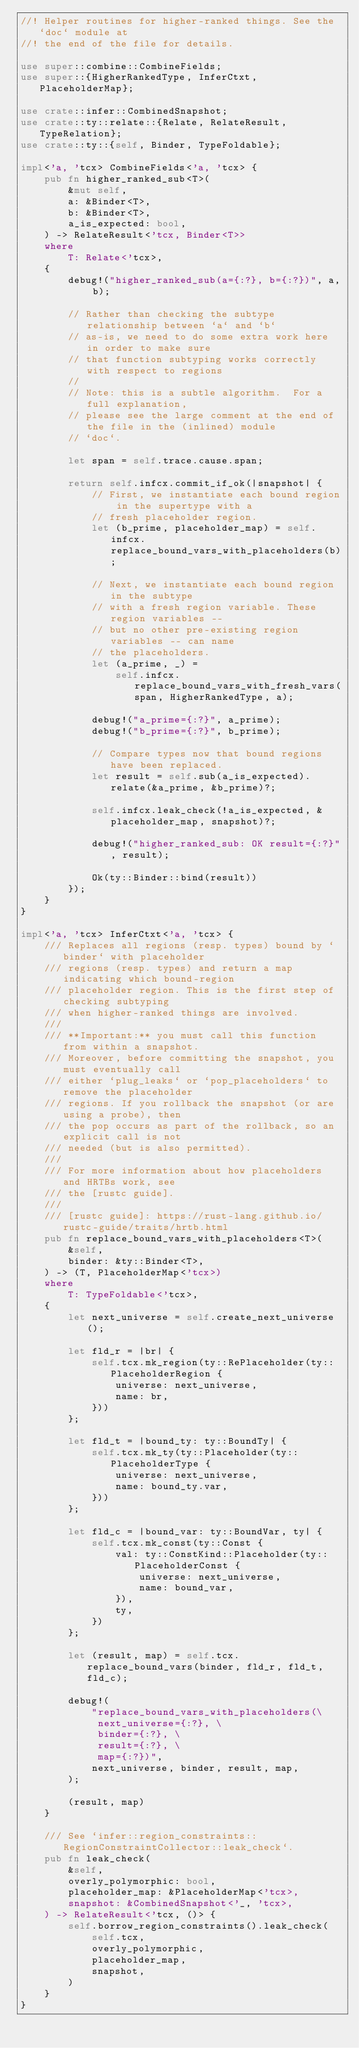<code> <loc_0><loc_0><loc_500><loc_500><_Rust_>//! Helper routines for higher-ranked things. See the `doc` module at
//! the end of the file for details.

use super::combine::CombineFields;
use super::{HigherRankedType, InferCtxt, PlaceholderMap};

use crate::infer::CombinedSnapshot;
use crate::ty::relate::{Relate, RelateResult, TypeRelation};
use crate::ty::{self, Binder, TypeFoldable};

impl<'a, 'tcx> CombineFields<'a, 'tcx> {
    pub fn higher_ranked_sub<T>(
        &mut self,
        a: &Binder<T>,
        b: &Binder<T>,
        a_is_expected: bool,
    ) -> RelateResult<'tcx, Binder<T>>
    where
        T: Relate<'tcx>,
    {
        debug!("higher_ranked_sub(a={:?}, b={:?})", a, b);

        // Rather than checking the subtype relationship between `a` and `b`
        // as-is, we need to do some extra work here in order to make sure
        // that function subtyping works correctly with respect to regions
        //
        // Note: this is a subtle algorithm.  For a full explanation,
        // please see the large comment at the end of the file in the (inlined) module
        // `doc`.

        let span = self.trace.cause.span;

        return self.infcx.commit_if_ok(|snapshot| {
            // First, we instantiate each bound region in the supertype with a
            // fresh placeholder region.
            let (b_prime, placeholder_map) = self.infcx.replace_bound_vars_with_placeholders(b);

            // Next, we instantiate each bound region in the subtype
            // with a fresh region variable. These region variables --
            // but no other pre-existing region variables -- can name
            // the placeholders.
            let (a_prime, _) =
                self.infcx.replace_bound_vars_with_fresh_vars(span, HigherRankedType, a);

            debug!("a_prime={:?}", a_prime);
            debug!("b_prime={:?}", b_prime);

            // Compare types now that bound regions have been replaced.
            let result = self.sub(a_is_expected).relate(&a_prime, &b_prime)?;

            self.infcx.leak_check(!a_is_expected, &placeholder_map, snapshot)?;

            debug!("higher_ranked_sub: OK result={:?}", result);

            Ok(ty::Binder::bind(result))
        });
    }
}

impl<'a, 'tcx> InferCtxt<'a, 'tcx> {
    /// Replaces all regions (resp. types) bound by `binder` with placeholder
    /// regions (resp. types) and return a map indicating which bound-region
    /// placeholder region. This is the first step of checking subtyping
    /// when higher-ranked things are involved.
    ///
    /// **Important:** you must call this function from within a snapshot.
    /// Moreover, before committing the snapshot, you must eventually call
    /// either `plug_leaks` or `pop_placeholders` to remove the placeholder
    /// regions. If you rollback the snapshot (or are using a probe), then
    /// the pop occurs as part of the rollback, so an explicit call is not
    /// needed (but is also permitted).
    ///
    /// For more information about how placeholders and HRTBs work, see
    /// the [rustc guide].
    ///
    /// [rustc guide]: https://rust-lang.github.io/rustc-guide/traits/hrtb.html
    pub fn replace_bound_vars_with_placeholders<T>(
        &self,
        binder: &ty::Binder<T>,
    ) -> (T, PlaceholderMap<'tcx>)
    where
        T: TypeFoldable<'tcx>,
    {
        let next_universe = self.create_next_universe();

        let fld_r = |br| {
            self.tcx.mk_region(ty::RePlaceholder(ty::PlaceholderRegion {
                universe: next_universe,
                name: br,
            }))
        };

        let fld_t = |bound_ty: ty::BoundTy| {
            self.tcx.mk_ty(ty::Placeholder(ty::PlaceholderType {
                universe: next_universe,
                name: bound_ty.var,
            }))
        };

        let fld_c = |bound_var: ty::BoundVar, ty| {
            self.tcx.mk_const(ty::Const {
                val: ty::ConstKind::Placeholder(ty::PlaceholderConst {
                    universe: next_universe,
                    name: bound_var,
                }),
                ty,
            })
        };

        let (result, map) = self.tcx.replace_bound_vars(binder, fld_r, fld_t, fld_c);

        debug!(
            "replace_bound_vars_with_placeholders(\
             next_universe={:?}, \
             binder={:?}, \
             result={:?}, \
             map={:?})",
            next_universe, binder, result, map,
        );

        (result, map)
    }

    /// See `infer::region_constraints::RegionConstraintCollector::leak_check`.
    pub fn leak_check(
        &self,
        overly_polymorphic: bool,
        placeholder_map: &PlaceholderMap<'tcx>,
        snapshot: &CombinedSnapshot<'_, 'tcx>,
    ) -> RelateResult<'tcx, ()> {
        self.borrow_region_constraints().leak_check(
            self.tcx,
            overly_polymorphic,
            placeholder_map,
            snapshot,
        )
    }
}
</code> 